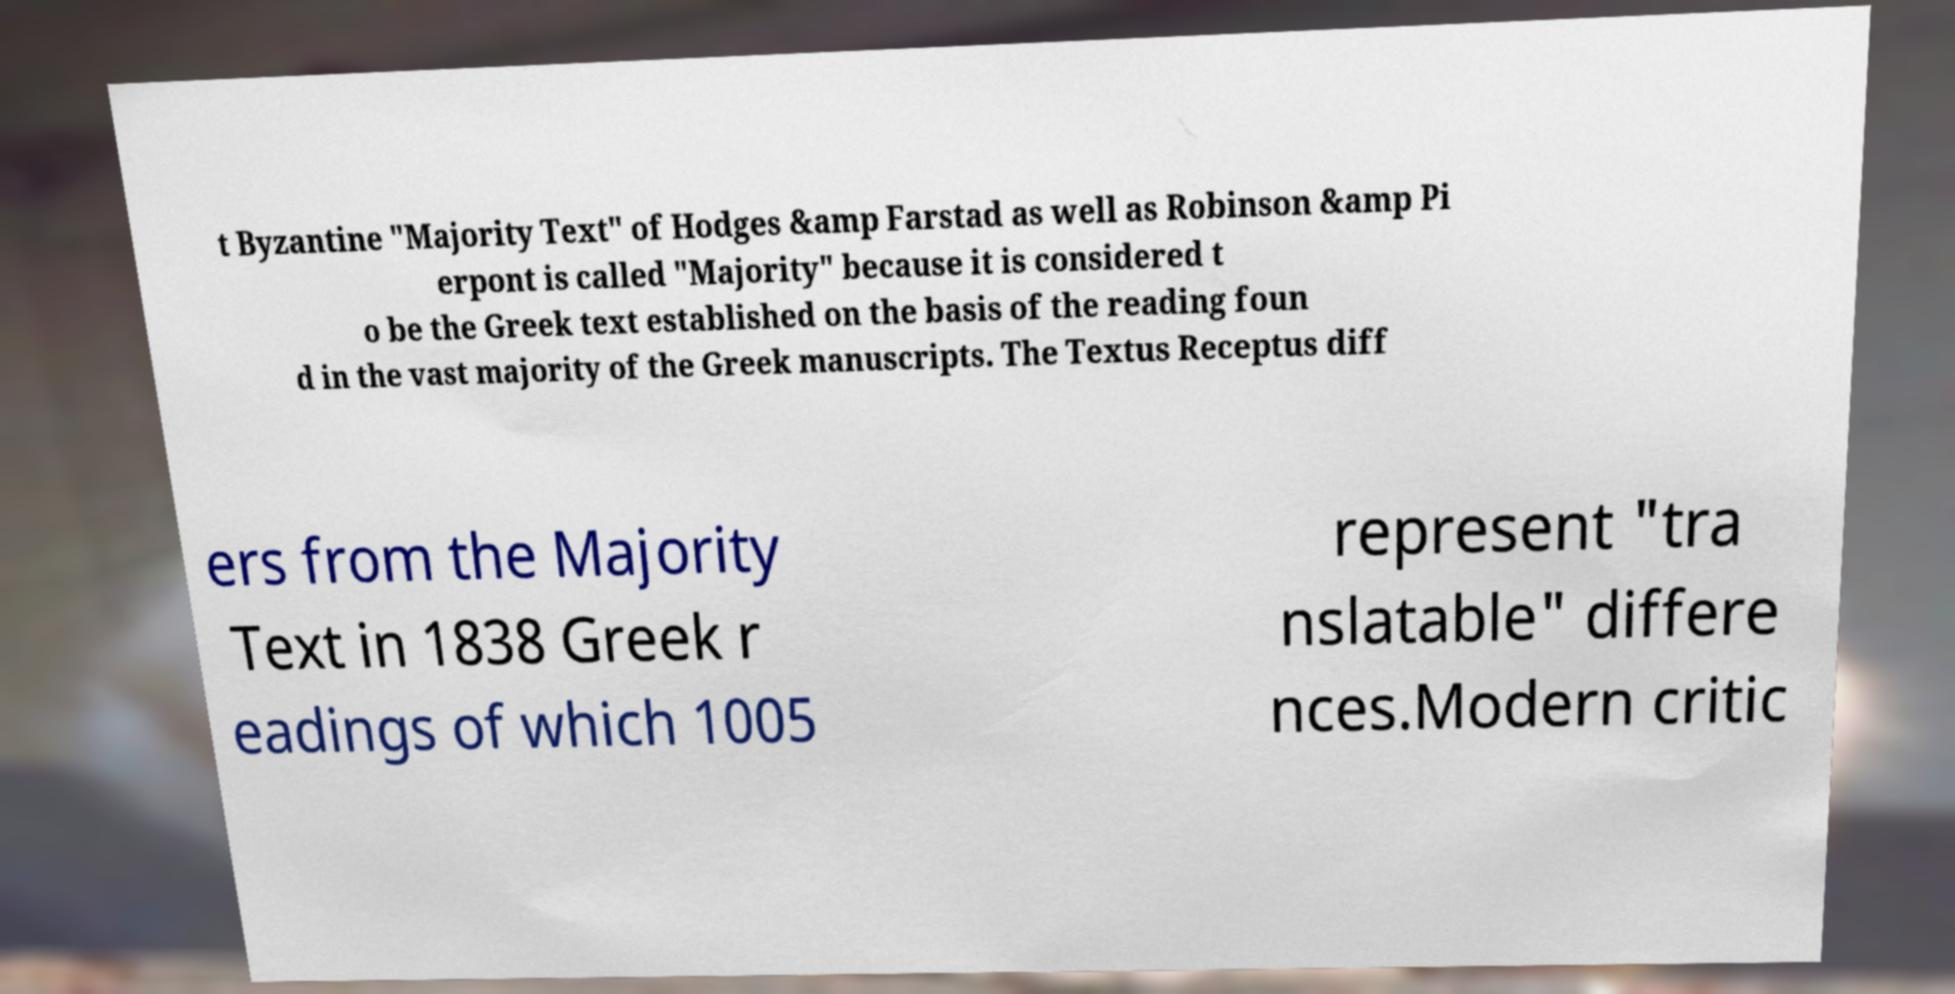Can you read and provide the text displayed in the image?This photo seems to have some interesting text. Can you extract and type it out for me? t Byzantine "Majority Text" of Hodges &amp Farstad as well as Robinson &amp Pi erpont is called "Majority" because it is considered t o be the Greek text established on the basis of the reading foun d in the vast majority of the Greek manuscripts. The Textus Receptus diff ers from the Majority Text in 1838 Greek r eadings of which 1005 represent "tra nslatable" differe nces.Modern critic 